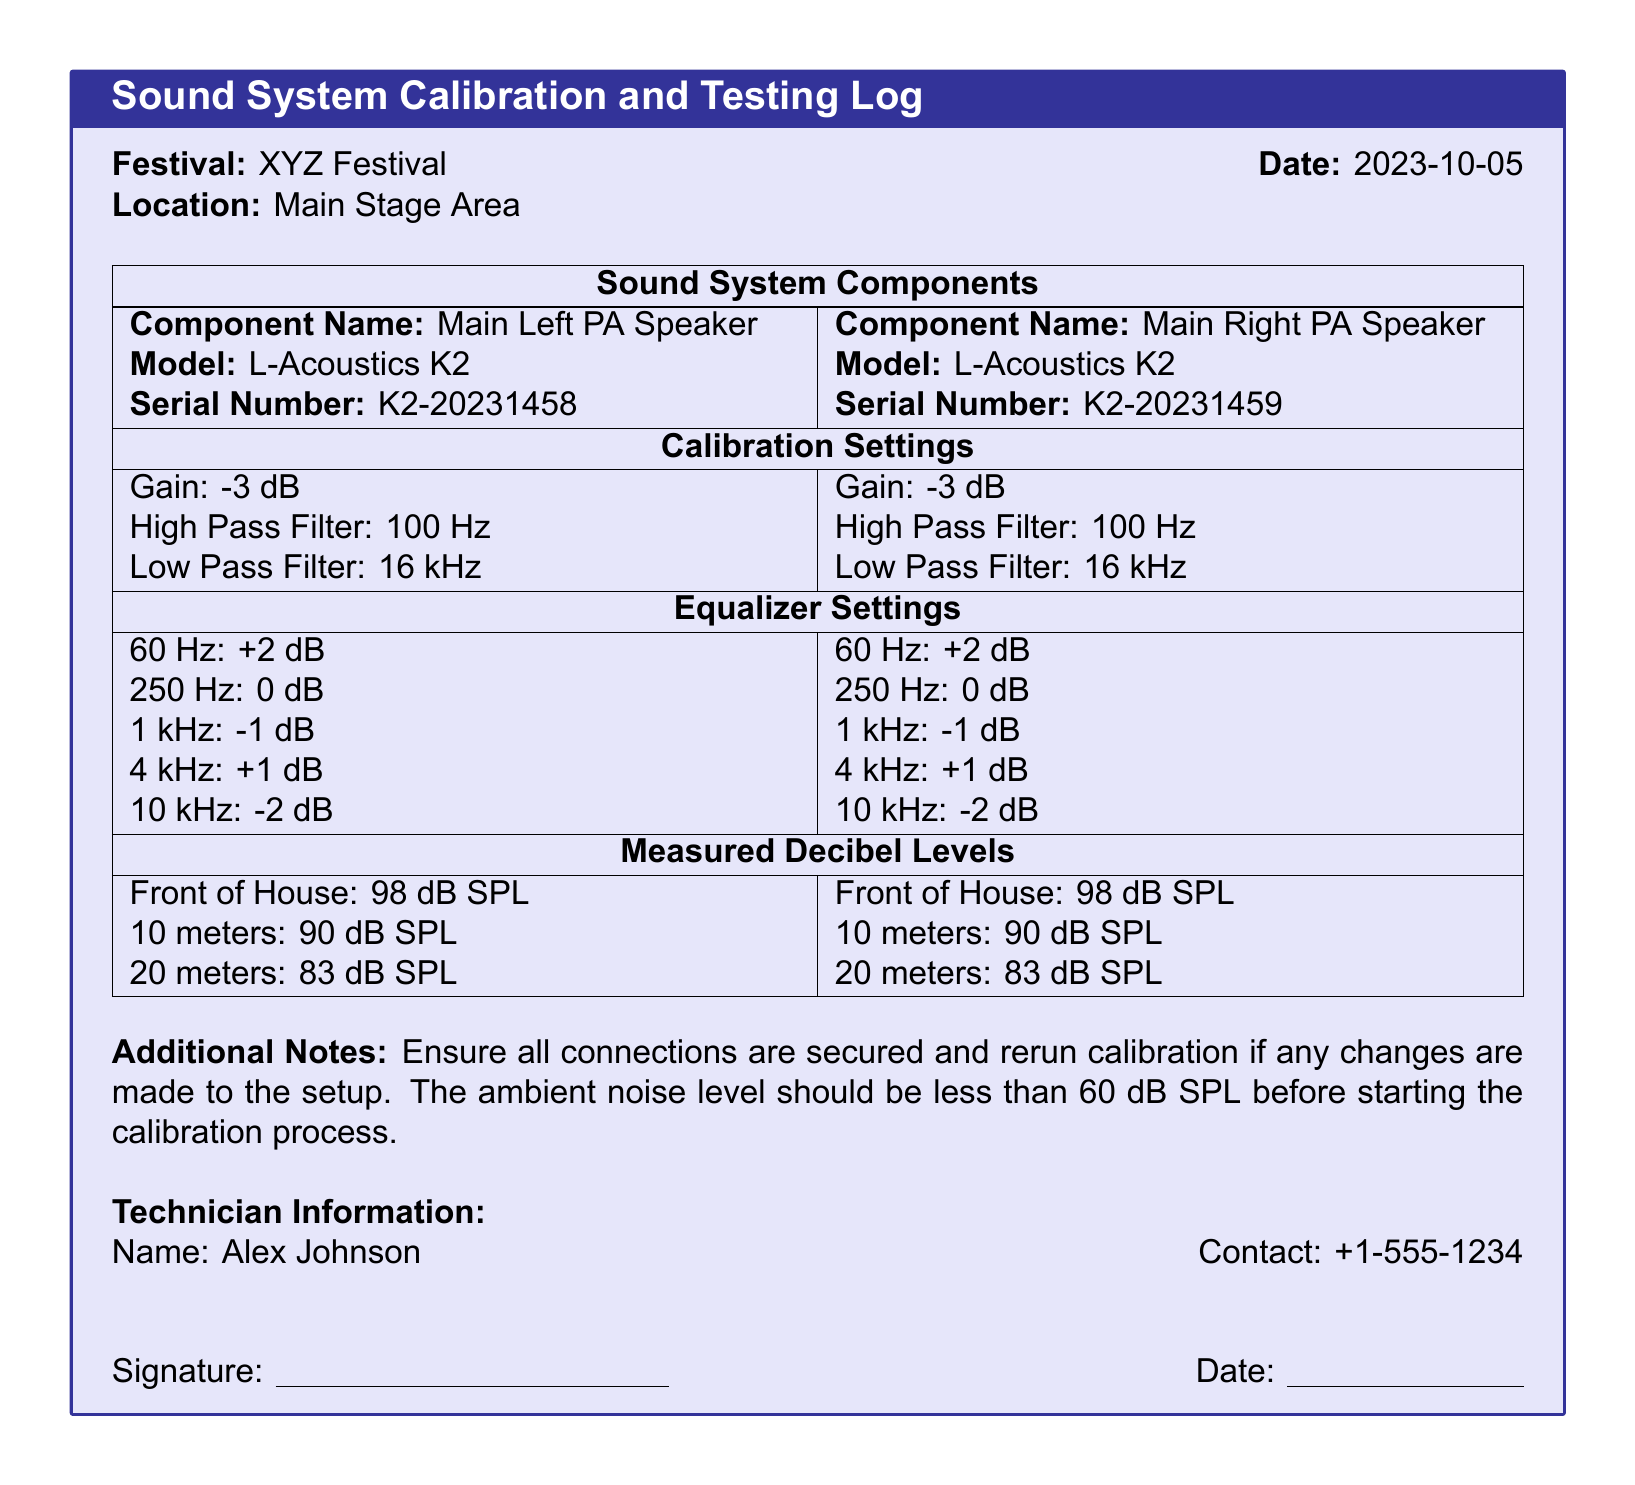What is the festival name? The document states the name of the festival in the title section, which is XYZ Festival.
Answer: XYZ Festival What is the date of the event? The date is provided next to the festival name in the document, which is 2023-10-05.
Answer: 2023-10-05 What is the model of the Main Left PA Speaker? The model is mentioned specifically in the component details, which is L-Acoustics K2.
Answer: L-Acoustics K2 What is the gain setting for the Main Right PA Speaker? The gain reading is listed under calibration settings in the document, which is -3 dB.
Answer: -3 dB What is the measured decibel level at 20 meters? The measured levels are provided in the table, specifically noted as 83 dB SPL for both speakers at this distance.
Answer: 83 dB SPL Who is the technician responsible for the calibration? The technician's information is listed at the end of the document, and their name is Alex Johnson.
Answer: Alex Johnson What is the high pass filter setting for both speakers? Calibration settings for both speakers indicate the high pass filter is set at 100 Hz.
Answer: 100 Hz What is the contact number for the technician? The technician's contact information is available in the document, which is +1-555-1234.
Answer: +1-555-1234 What should be done if changes are made to the setup? The document notes that calibration should be rerun if any changes are made, indicating the need for thorough checks.
Answer: Rerun calibration 